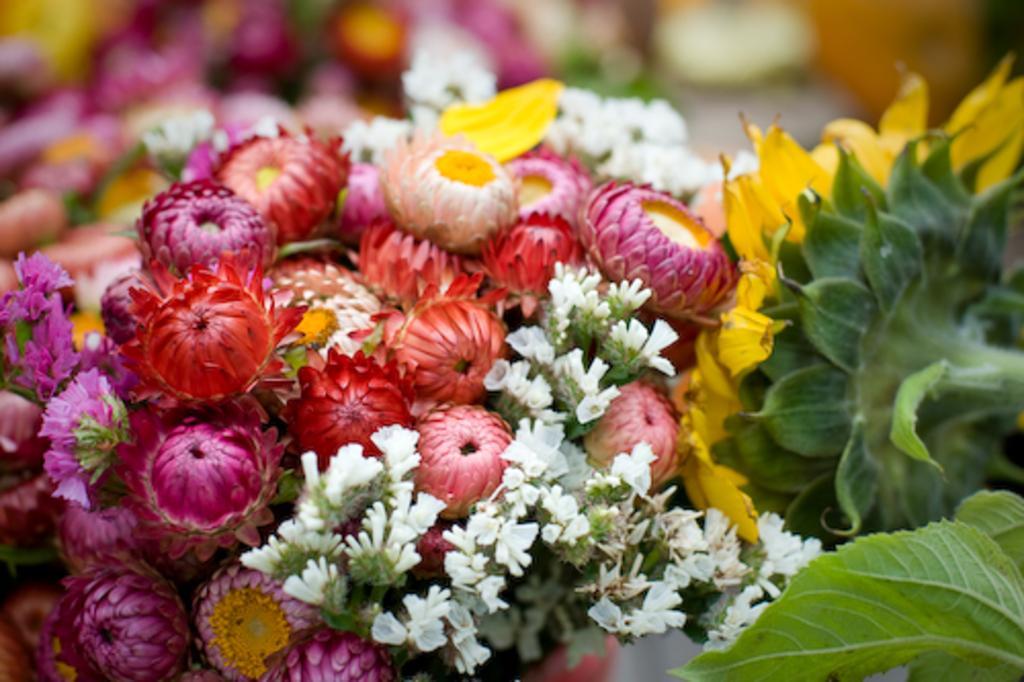Please provide a concise description of this image. In this picture we can see different kinds of flowers and leaves. Behind the flowers there are blurred things. 